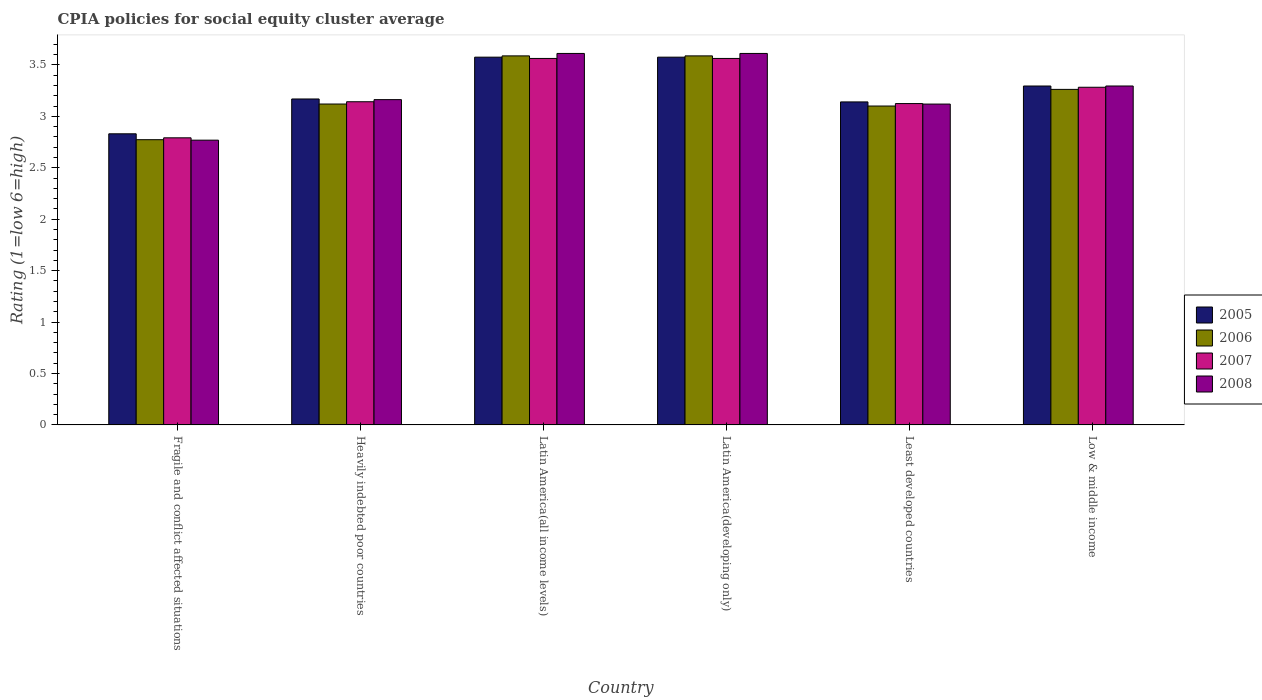Are the number of bars on each tick of the X-axis equal?
Your response must be concise. Yes. How many bars are there on the 6th tick from the left?
Provide a short and direct response. 4. How many bars are there on the 6th tick from the right?
Offer a terse response. 4. What is the label of the 3rd group of bars from the left?
Ensure brevity in your answer.  Latin America(all income levels). In how many cases, is the number of bars for a given country not equal to the number of legend labels?
Provide a short and direct response. 0. Across all countries, what is the maximum CPIA rating in 2006?
Provide a short and direct response. 3.59. Across all countries, what is the minimum CPIA rating in 2008?
Your response must be concise. 2.77. In which country was the CPIA rating in 2005 maximum?
Offer a terse response. Latin America(all income levels). In which country was the CPIA rating in 2008 minimum?
Provide a short and direct response. Fragile and conflict affected situations. What is the total CPIA rating in 2008 in the graph?
Offer a very short reply. 19.57. What is the difference between the CPIA rating in 2008 in Latin America(all income levels) and that in Low & middle income?
Provide a short and direct response. 0.32. What is the difference between the CPIA rating in 2007 in Heavily indebted poor countries and the CPIA rating in 2008 in Low & middle income?
Ensure brevity in your answer.  -0.15. What is the average CPIA rating in 2005 per country?
Offer a terse response. 3.26. What is the difference between the CPIA rating of/in 2005 and CPIA rating of/in 2006 in Latin America(all income levels)?
Provide a short and direct response. -0.01. In how many countries, is the CPIA rating in 2007 greater than 3.3?
Make the answer very short. 2. What is the ratio of the CPIA rating in 2007 in Fragile and conflict affected situations to that in Least developed countries?
Your answer should be compact. 0.89. Is the CPIA rating in 2006 in Latin America(all income levels) less than that in Latin America(developing only)?
Provide a succinct answer. No. What is the difference between the highest and the second highest CPIA rating in 2005?
Make the answer very short. -0.28. What is the difference between the highest and the lowest CPIA rating in 2007?
Provide a short and direct response. 0.77. In how many countries, is the CPIA rating in 2006 greater than the average CPIA rating in 2006 taken over all countries?
Provide a succinct answer. 3. Is the sum of the CPIA rating in 2008 in Latin America(all income levels) and Low & middle income greater than the maximum CPIA rating in 2007 across all countries?
Provide a succinct answer. Yes. What does the 4th bar from the right in Latin America(developing only) represents?
Give a very brief answer. 2005. Is it the case that in every country, the sum of the CPIA rating in 2005 and CPIA rating in 2007 is greater than the CPIA rating in 2008?
Give a very brief answer. Yes. How many bars are there?
Make the answer very short. 24. How many countries are there in the graph?
Your answer should be very brief. 6. Are the values on the major ticks of Y-axis written in scientific E-notation?
Ensure brevity in your answer.  No. How many legend labels are there?
Ensure brevity in your answer.  4. How are the legend labels stacked?
Your answer should be compact. Vertical. What is the title of the graph?
Give a very brief answer. CPIA policies for social equity cluster average. Does "2005" appear as one of the legend labels in the graph?
Make the answer very short. Yes. What is the label or title of the X-axis?
Give a very brief answer. Country. What is the label or title of the Y-axis?
Offer a terse response. Rating (1=low 6=high). What is the Rating (1=low 6=high) of 2005 in Fragile and conflict affected situations?
Provide a short and direct response. 2.83. What is the Rating (1=low 6=high) of 2006 in Fragile and conflict affected situations?
Keep it short and to the point. 2.77. What is the Rating (1=low 6=high) in 2007 in Fragile and conflict affected situations?
Your response must be concise. 2.79. What is the Rating (1=low 6=high) of 2008 in Fragile and conflict affected situations?
Offer a very short reply. 2.77. What is the Rating (1=low 6=high) of 2005 in Heavily indebted poor countries?
Offer a terse response. 3.17. What is the Rating (1=low 6=high) in 2006 in Heavily indebted poor countries?
Keep it short and to the point. 3.12. What is the Rating (1=low 6=high) in 2007 in Heavily indebted poor countries?
Your answer should be compact. 3.14. What is the Rating (1=low 6=high) in 2008 in Heavily indebted poor countries?
Keep it short and to the point. 3.16. What is the Rating (1=low 6=high) in 2005 in Latin America(all income levels)?
Your answer should be very brief. 3.58. What is the Rating (1=low 6=high) in 2006 in Latin America(all income levels)?
Your response must be concise. 3.59. What is the Rating (1=low 6=high) in 2007 in Latin America(all income levels)?
Provide a short and direct response. 3.56. What is the Rating (1=low 6=high) of 2008 in Latin America(all income levels)?
Keep it short and to the point. 3.61. What is the Rating (1=low 6=high) of 2005 in Latin America(developing only)?
Keep it short and to the point. 3.58. What is the Rating (1=low 6=high) in 2006 in Latin America(developing only)?
Make the answer very short. 3.59. What is the Rating (1=low 6=high) of 2007 in Latin America(developing only)?
Offer a very short reply. 3.56. What is the Rating (1=low 6=high) in 2008 in Latin America(developing only)?
Provide a short and direct response. 3.61. What is the Rating (1=low 6=high) of 2005 in Least developed countries?
Your response must be concise. 3.14. What is the Rating (1=low 6=high) of 2007 in Least developed countries?
Your answer should be compact. 3.12. What is the Rating (1=low 6=high) in 2008 in Least developed countries?
Provide a short and direct response. 3.12. What is the Rating (1=low 6=high) of 2005 in Low & middle income?
Provide a succinct answer. 3.29. What is the Rating (1=low 6=high) of 2006 in Low & middle income?
Give a very brief answer. 3.26. What is the Rating (1=low 6=high) of 2007 in Low & middle income?
Your response must be concise. 3.28. What is the Rating (1=low 6=high) in 2008 in Low & middle income?
Offer a terse response. 3.29. Across all countries, what is the maximum Rating (1=low 6=high) in 2005?
Make the answer very short. 3.58. Across all countries, what is the maximum Rating (1=low 6=high) in 2006?
Ensure brevity in your answer.  3.59. Across all countries, what is the maximum Rating (1=low 6=high) in 2007?
Your answer should be compact. 3.56. Across all countries, what is the maximum Rating (1=low 6=high) in 2008?
Give a very brief answer. 3.61. Across all countries, what is the minimum Rating (1=low 6=high) of 2005?
Ensure brevity in your answer.  2.83. Across all countries, what is the minimum Rating (1=low 6=high) in 2006?
Your answer should be very brief. 2.77. Across all countries, what is the minimum Rating (1=low 6=high) in 2007?
Offer a terse response. 2.79. Across all countries, what is the minimum Rating (1=low 6=high) in 2008?
Ensure brevity in your answer.  2.77. What is the total Rating (1=low 6=high) in 2005 in the graph?
Keep it short and to the point. 19.58. What is the total Rating (1=low 6=high) of 2006 in the graph?
Offer a terse response. 19.43. What is the total Rating (1=low 6=high) of 2007 in the graph?
Provide a succinct answer. 19.46. What is the total Rating (1=low 6=high) in 2008 in the graph?
Your response must be concise. 19.57. What is the difference between the Rating (1=low 6=high) of 2005 in Fragile and conflict affected situations and that in Heavily indebted poor countries?
Your answer should be very brief. -0.34. What is the difference between the Rating (1=low 6=high) in 2006 in Fragile and conflict affected situations and that in Heavily indebted poor countries?
Your answer should be compact. -0.35. What is the difference between the Rating (1=low 6=high) in 2007 in Fragile and conflict affected situations and that in Heavily indebted poor countries?
Make the answer very short. -0.35. What is the difference between the Rating (1=low 6=high) in 2008 in Fragile and conflict affected situations and that in Heavily indebted poor countries?
Your answer should be compact. -0.39. What is the difference between the Rating (1=low 6=high) in 2005 in Fragile and conflict affected situations and that in Latin America(all income levels)?
Your answer should be very brief. -0.74. What is the difference between the Rating (1=low 6=high) of 2006 in Fragile and conflict affected situations and that in Latin America(all income levels)?
Your answer should be compact. -0.81. What is the difference between the Rating (1=low 6=high) of 2007 in Fragile and conflict affected situations and that in Latin America(all income levels)?
Your response must be concise. -0.77. What is the difference between the Rating (1=low 6=high) of 2008 in Fragile and conflict affected situations and that in Latin America(all income levels)?
Provide a short and direct response. -0.84. What is the difference between the Rating (1=low 6=high) in 2005 in Fragile and conflict affected situations and that in Latin America(developing only)?
Make the answer very short. -0.74. What is the difference between the Rating (1=low 6=high) of 2006 in Fragile and conflict affected situations and that in Latin America(developing only)?
Give a very brief answer. -0.81. What is the difference between the Rating (1=low 6=high) of 2007 in Fragile and conflict affected situations and that in Latin America(developing only)?
Provide a succinct answer. -0.77. What is the difference between the Rating (1=low 6=high) of 2008 in Fragile and conflict affected situations and that in Latin America(developing only)?
Provide a succinct answer. -0.84. What is the difference between the Rating (1=low 6=high) in 2005 in Fragile and conflict affected situations and that in Least developed countries?
Keep it short and to the point. -0.31. What is the difference between the Rating (1=low 6=high) in 2006 in Fragile and conflict affected situations and that in Least developed countries?
Keep it short and to the point. -0.33. What is the difference between the Rating (1=low 6=high) in 2007 in Fragile and conflict affected situations and that in Least developed countries?
Ensure brevity in your answer.  -0.33. What is the difference between the Rating (1=low 6=high) in 2008 in Fragile and conflict affected situations and that in Least developed countries?
Provide a succinct answer. -0.35. What is the difference between the Rating (1=low 6=high) in 2005 in Fragile and conflict affected situations and that in Low & middle income?
Ensure brevity in your answer.  -0.46. What is the difference between the Rating (1=low 6=high) of 2006 in Fragile and conflict affected situations and that in Low & middle income?
Give a very brief answer. -0.49. What is the difference between the Rating (1=low 6=high) of 2007 in Fragile and conflict affected situations and that in Low & middle income?
Ensure brevity in your answer.  -0.49. What is the difference between the Rating (1=low 6=high) in 2008 in Fragile and conflict affected situations and that in Low & middle income?
Provide a short and direct response. -0.53. What is the difference between the Rating (1=low 6=high) of 2005 in Heavily indebted poor countries and that in Latin America(all income levels)?
Offer a very short reply. -0.41. What is the difference between the Rating (1=low 6=high) in 2006 in Heavily indebted poor countries and that in Latin America(all income levels)?
Provide a succinct answer. -0.47. What is the difference between the Rating (1=low 6=high) in 2007 in Heavily indebted poor countries and that in Latin America(all income levels)?
Provide a short and direct response. -0.42. What is the difference between the Rating (1=low 6=high) of 2008 in Heavily indebted poor countries and that in Latin America(all income levels)?
Your response must be concise. -0.45. What is the difference between the Rating (1=low 6=high) in 2005 in Heavily indebted poor countries and that in Latin America(developing only)?
Make the answer very short. -0.41. What is the difference between the Rating (1=low 6=high) of 2006 in Heavily indebted poor countries and that in Latin America(developing only)?
Provide a succinct answer. -0.47. What is the difference between the Rating (1=low 6=high) of 2007 in Heavily indebted poor countries and that in Latin America(developing only)?
Provide a succinct answer. -0.42. What is the difference between the Rating (1=low 6=high) of 2008 in Heavily indebted poor countries and that in Latin America(developing only)?
Provide a short and direct response. -0.45. What is the difference between the Rating (1=low 6=high) in 2005 in Heavily indebted poor countries and that in Least developed countries?
Ensure brevity in your answer.  0.03. What is the difference between the Rating (1=low 6=high) of 2006 in Heavily indebted poor countries and that in Least developed countries?
Your answer should be compact. 0.02. What is the difference between the Rating (1=low 6=high) in 2007 in Heavily indebted poor countries and that in Least developed countries?
Ensure brevity in your answer.  0.02. What is the difference between the Rating (1=low 6=high) of 2008 in Heavily indebted poor countries and that in Least developed countries?
Offer a very short reply. 0.04. What is the difference between the Rating (1=low 6=high) in 2005 in Heavily indebted poor countries and that in Low & middle income?
Offer a very short reply. -0.13. What is the difference between the Rating (1=low 6=high) of 2006 in Heavily indebted poor countries and that in Low & middle income?
Provide a succinct answer. -0.14. What is the difference between the Rating (1=low 6=high) in 2007 in Heavily indebted poor countries and that in Low & middle income?
Your answer should be very brief. -0.14. What is the difference between the Rating (1=low 6=high) of 2008 in Heavily indebted poor countries and that in Low & middle income?
Ensure brevity in your answer.  -0.13. What is the difference between the Rating (1=low 6=high) in 2007 in Latin America(all income levels) and that in Latin America(developing only)?
Make the answer very short. 0. What is the difference between the Rating (1=low 6=high) of 2008 in Latin America(all income levels) and that in Latin America(developing only)?
Give a very brief answer. 0. What is the difference between the Rating (1=low 6=high) in 2005 in Latin America(all income levels) and that in Least developed countries?
Offer a very short reply. 0.43. What is the difference between the Rating (1=low 6=high) of 2006 in Latin America(all income levels) and that in Least developed countries?
Keep it short and to the point. 0.49. What is the difference between the Rating (1=low 6=high) in 2007 in Latin America(all income levels) and that in Least developed countries?
Offer a very short reply. 0.44. What is the difference between the Rating (1=low 6=high) of 2008 in Latin America(all income levels) and that in Least developed countries?
Ensure brevity in your answer.  0.49. What is the difference between the Rating (1=low 6=high) of 2005 in Latin America(all income levels) and that in Low & middle income?
Provide a short and direct response. 0.28. What is the difference between the Rating (1=low 6=high) in 2006 in Latin America(all income levels) and that in Low & middle income?
Provide a short and direct response. 0.33. What is the difference between the Rating (1=low 6=high) in 2007 in Latin America(all income levels) and that in Low & middle income?
Keep it short and to the point. 0.28. What is the difference between the Rating (1=low 6=high) of 2008 in Latin America(all income levels) and that in Low & middle income?
Keep it short and to the point. 0.32. What is the difference between the Rating (1=low 6=high) in 2005 in Latin America(developing only) and that in Least developed countries?
Offer a terse response. 0.43. What is the difference between the Rating (1=low 6=high) in 2006 in Latin America(developing only) and that in Least developed countries?
Keep it short and to the point. 0.49. What is the difference between the Rating (1=low 6=high) in 2007 in Latin America(developing only) and that in Least developed countries?
Keep it short and to the point. 0.44. What is the difference between the Rating (1=low 6=high) in 2008 in Latin America(developing only) and that in Least developed countries?
Your answer should be very brief. 0.49. What is the difference between the Rating (1=low 6=high) of 2005 in Latin America(developing only) and that in Low & middle income?
Make the answer very short. 0.28. What is the difference between the Rating (1=low 6=high) in 2006 in Latin America(developing only) and that in Low & middle income?
Keep it short and to the point. 0.33. What is the difference between the Rating (1=low 6=high) of 2007 in Latin America(developing only) and that in Low & middle income?
Your answer should be compact. 0.28. What is the difference between the Rating (1=low 6=high) in 2008 in Latin America(developing only) and that in Low & middle income?
Your answer should be compact. 0.32. What is the difference between the Rating (1=low 6=high) of 2005 in Least developed countries and that in Low & middle income?
Provide a succinct answer. -0.15. What is the difference between the Rating (1=low 6=high) in 2006 in Least developed countries and that in Low & middle income?
Ensure brevity in your answer.  -0.16. What is the difference between the Rating (1=low 6=high) in 2007 in Least developed countries and that in Low & middle income?
Offer a terse response. -0.16. What is the difference between the Rating (1=low 6=high) in 2008 in Least developed countries and that in Low & middle income?
Provide a succinct answer. -0.18. What is the difference between the Rating (1=low 6=high) of 2005 in Fragile and conflict affected situations and the Rating (1=low 6=high) of 2006 in Heavily indebted poor countries?
Give a very brief answer. -0.29. What is the difference between the Rating (1=low 6=high) in 2005 in Fragile and conflict affected situations and the Rating (1=low 6=high) in 2007 in Heavily indebted poor countries?
Your answer should be compact. -0.31. What is the difference between the Rating (1=low 6=high) in 2005 in Fragile and conflict affected situations and the Rating (1=low 6=high) in 2008 in Heavily indebted poor countries?
Your answer should be compact. -0.33. What is the difference between the Rating (1=low 6=high) of 2006 in Fragile and conflict affected situations and the Rating (1=low 6=high) of 2007 in Heavily indebted poor countries?
Ensure brevity in your answer.  -0.37. What is the difference between the Rating (1=low 6=high) in 2006 in Fragile and conflict affected situations and the Rating (1=low 6=high) in 2008 in Heavily indebted poor countries?
Your response must be concise. -0.39. What is the difference between the Rating (1=low 6=high) in 2007 in Fragile and conflict affected situations and the Rating (1=low 6=high) in 2008 in Heavily indebted poor countries?
Offer a terse response. -0.37. What is the difference between the Rating (1=low 6=high) of 2005 in Fragile and conflict affected situations and the Rating (1=low 6=high) of 2006 in Latin America(all income levels)?
Make the answer very short. -0.76. What is the difference between the Rating (1=low 6=high) of 2005 in Fragile and conflict affected situations and the Rating (1=low 6=high) of 2007 in Latin America(all income levels)?
Keep it short and to the point. -0.73. What is the difference between the Rating (1=low 6=high) in 2005 in Fragile and conflict affected situations and the Rating (1=low 6=high) in 2008 in Latin America(all income levels)?
Provide a short and direct response. -0.78. What is the difference between the Rating (1=low 6=high) of 2006 in Fragile and conflict affected situations and the Rating (1=low 6=high) of 2007 in Latin America(all income levels)?
Your answer should be very brief. -0.79. What is the difference between the Rating (1=low 6=high) of 2006 in Fragile and conflict affected situations and the Rating (1=low 6=high) of 2008 in Latin America(all income levels)?
Keep it short and to the point. -0.84. What is the difference between the Rating (1=low 6=high) in 2007 in Fragile and conflict affected situations and the Rating (1=low 6=high) in 2008 in Latin America(all income levels)?
Offer a very short reply. -0.82. What is the difference between the Rating (1=low 6=high) in 2005 in Fragile and conflict affected situations and the Rating (1=low 6=high) in 2006 in Latin America(developing only)?
Your answer should be very brief. -0.76. What is the difference between the Rating (1=low 6=high) of 2005 in Fragile and conflict affected situations and the Rating (1=low 6=high) of 2007 in Latin America(developing only)?
Your answer should be compact. -0.73. What is the difference between the Rating (1=low 6=high) in 2005 in Fragile and conflict affected situations and the Rating (1=low 6=high) in 2008 in Latin America(developing only)?
Make the answer very short. -0.78. What is the difference between the Rating (1=low 6=high) in 2006 in Fragile and conflict affected situations and the Rating (1=low 6=high) in 2007 in Latin America(developing only)?
Offer a very short reply. -0.79. What is the difference between the Rating (1=low 6=high) of 2006 in Fragile and conflict affected situations and the Rating (1=low 6=high) of 2008 in Latin America(developing only)?
Offer a terse response. -0.84. What is the difference between the Rating (1=low 6=high) in 2007 in Fragile and conflict affected situations and the Rating (1=low 6=high) in 2008 in Latin America(developing only)?
Keep it short and to the point. -0.82. What is the difference between the Rating (1=low 6=high) of 2005 in Fragile and conflict affected situations and the Rating (1=low 6=high) of 2006 in Least developed countries?
Make the answer very short. -0.27. What is the difference between the Rating (1=low 6=high) in 2005 in Fragile and conflict affected situations and the Rating (1=low 6=high) in 2007 in Least developed countries?
Your response must be concise. -0.29. What is the difference between the Rating (1=low 6=high) in 2005 in Fragile and conflict affected situations and the Rating (1=low 6=high) in 2008 in Least developed countries?
Your answer should be compact. -0.29. What is the difference between the Rating (1=low 6=high) in 2006 in Fragile and conflict affected situations and the Rating (1=low 6=high) in 2007 in Least developed countries?
Provide a short and direct response. -0.35. What is the difference between the Rating (1=low 6=high) of 2006 in Fragile and conflict affected situations and the Rating (1=low 6=high) of 2008 in Least developed countries?
Make the answer very short. -0.35. What is the difference between the Rating (1=low 6=high) in 2007 in Fragile and conflict affected situations and the Rating (1=low 6=high) in 2008 in Least developed countries?
Provide a succinct answer. -0.33. What is the difference between the Rating (1=low 6=high) of 2005 in Fragile and conflict affected situations and the Rating (1=low 6=high) of 2006 in Low & middle income?
Offer a terse response. -0.43. What is the difference between the Rating (1=low 6=high) of 2005 in Fragile and conflict affected situations and the Rating (1=low 6=high) of 2007 in Low & middle income?
Offer a terse response. -0.45. What is the difference between the Rating (1=low 6=high) of 2005 in Fragile and conflict affected situations and the Rating (1=low 6=high) of 2008 in Low & middle income?
Keep it short and to the point. -0.46. What is the difference between the Rating (1=low 6=high) of 2006 in Fragile and conflict affected situations and the Rating (1=low 6=high) of 2007 in Low & middle income?
Your response must be concise. -0.51. What is the difference between the Rating (1=low 6=high) in 2006 in Fragile and conflict affected situations and the Rating (1=low 6=high) in 2008 in Low & middle income?
Provide a succinct answer. -0.52. What is the difference between the Rating (1=low 6=high) of 2007 in Fragile and conflict affected situations and the Rating (1=low 6=high) of 2008 in Low & middle income?
Provide a short and direct response. -0.5. What is the difference between the Rating (1=low 6=high) of 2005 in Heavily indebted poor countries and the Rating (1=low 6=high) of 2006 in Latin America(all income levels)?
Your answer should be compact. -0.42. What is the difference between the Rating (1=low 6=high) in 2005 in Heavily indebted poor countries and the Rating (1=low 6=high) in 2007 in Latin America(all income levels)?
Make the answer very short. -0.39. What is the difference between the Rating (1=low 6=high) of 2005 in Heavily indebted poor countries and the Rating (1=low 6=high) of 2008 in Latin America(all income levels)?
Your answer should be compact. -0.44. What is the difference between the Rating (1=low 6=high) in 2006 in Heavily indebted poor countries and the Rating (1=low 6=high) in 2007 in Latin America(all income levels)?
Give a very brief answer. -0.44. What is the difference between the Rating (1=low 6=high) of 2006 in Heavily indebted poor countries and the Rating (1=low 6=high) of 2008 in Latin America(all income levels)?
Make the answer very short. -0.49. What is the difference between the Rating (1=low 6=high) of 2007 in Heavily indebted poor countries and the Rating (1=low 6=high) of 2008 in Latin America(all income levels)?
Provide a short and direct response. -0.47. What is the difference between the Rating (1=low 6=high) in 2005 in Heavily indebted poor countries and the Rating (1=low 6=high) in 2006 in Latin America(developing only)?
Keep it short and to the point. -0.42. What is the difference between the Rating (1=low 6=high) of 2005 in Heavily indebted poor countries and the Rating (1=low 6=high) of 2007 in Latin America(developing only)?
Your answer should be very brief. -0.39. What is the difference between the Rating (1=low 6=high) in 2005 in Heavily indebted poor countries and the Rating (1=low 6=high) in 2008 in Latin America(developing only)?
Provide a short and direct response. -0.44. What is the difference between the Rating (1=low 6=high) of 2006 in Heavily indebted poor countries and the Rating (1=low 6=high) of 2007 in Latin America(developing only)?
Offer a very short reply. -0.44. What is the difference between the Rating (1=low 6=high) in 2006 in Heavily indebted poor countries and the Rating (1=low 6=high) in 2008 in Latin America(developing only)?
Offer a terse response. -0.49. What is the difference between the Rating (1=low 6=high) of 2007 in Heavily indebted poor countries and the Rating (1=low 6=high) of 2008 in Latin America(developing only)?
Keep it short and to the point. -0.47. What is the difference between the Rating (1=low 6=high) in 2005 in Heavily indebted poor countries and the Rating (1=low 6=high) in 2006 in Least developed countries?
Provide a succinct answer. 0.07. What is the difference between the Rating (1=low 6=high) in 2005 in Heavily indebted poor countries and the Rating (1=low 6=high) in 2007 in Least developed countries?
Make the answer very short. 0.04. What is the difference between the Rating (1=low 6=high) in 2005 in Heavily indebted poor countries and the Rating (1=low 6=high) in 2008 in Least developed countries?
Provide a succinct answer. 0.05. What is the difference between the Rating (1=low 6=high) in 2006 in Heavily indebted poor countries and the Rating (1=low 6=high) in 2007 in Least developed countries?
Provide a succinct answer. -0. What is the difference between the Rating (1=low 6=high) in 2007 in Heavily indebted poor countries and the Rating (1=low 6=high) in 2008 in Least developed countries?
Your answer should be very brief. 0.02. What is the difference between the Rating (1=low 6=high) of 2005 in Heavily indebted poor countries and the Rating (1=low 6=high) of 2006 in Low & middle income?
Ensure brevity in your answer.  -0.09. What is the difference between the Rating (1=low 6=high) of 2005 in Heavily indebted poor countries and the Rating (1=low 6=high) of 2007 in Low & middle income?
Offer a very short reply. -0.11. What is the difference between the Rating (1=low 6=high) of 2005 in Heavily indebted poor countries and the Rating (1=low 6=high) of 2008 in Low & middle income?
Ensure brevity in your answer.  -0.13. What is the difference between the Rating (1=low 6=high) of 2006 in Heavily indebted poor countries and the Rating (1=low 6=high) of 2007 in Low & middle income?
Make the answer very short. -0.16. What is the difference between the Rating (1=low 6=high) of 2006 in Heavily indebted poor countries and the Rating (1=low 6=high) of 2008 in Low & middle income?
Offer a very short reply. -0.18. What is the difference between the Rating (1=low 6=high) of 2007 in Heavily indebted poor countries and the Rating (1=low 6=high) of 2008 in Low & middle income?
Your answer should be compact. -0.15. What is the difference between the Rating (1=low 6=high) in 2005 in Latin America(all income levels) and the Rating (1=low 6=high) in 2006 in Latin America(developing only)?
Offer a terse response. -0.01. What is the difference between the Rating (1=low 6=high) of 2005 in Latin America(all income levels) and the Rating (1=low 6=high) of 2007 in Latin America(developing only)?
Your answer should be very brief. 0.01. What is the difference between the Rating (1=low 6=high) of 2005 in Latin America(all income levels) and the Rating (1=low 6=high) of 2008 in Latin America(developing only)?
Your answer should be very brief. -0.04. What is the difference between the Rating (1=low 6=high) of 2006 in Latin America(all income levels) and the Rating (1=low 6=high) of 2007 in Latin America(developing only)?
Ensure brevity in your answer.  0.03. What is the difference between the Rating (1=low 6=high) of 2006 in Latin America(all income levels) and the Rating (1=low 6=high) of 2008 in Latin America(developing only)?
Provide a short and direct response. -0.02. What is the difference between the Rating (1=low 6=high) of 2007 in Latin America(all income levels) and the Rating (1=low 6=high) of 2008 in Latin America(developing only)?
Keep it short and to the point. -0.05. What is the difference between the Rating (1=low 6=high) in 2005 in Latin America(all income levels) and the Rating (1=low 6=high) in 2006 in Least developed countries?
Ensure brevity in your answer.  0.47. What is the difference between the Rating (1=low 6=high) of 2005 in Latin America(all income levels) and the Rating (1=low 6=high) of 2007 in Least developed countries?
Ensure brevity in your answer.  0.45. What is the difference between the Rating (1=low 6=high) of 2005 in Latin America(all income levels) and the Rating (1=low 6=high) of 2008 in Least developed countries?
Your answer should be very brief. 0.46. What is the difference between the Rating (1=low 6=high) of 2006 in Latin America(all income levels) and the Rating (1=low 6=high) of 2007 in Least developed countries?
Your answer should be very brief. 0.46. What is the difference between the Rating (1=low 6=high) in 2006 in Latin America(all income levels) and the Rating (1=low 6=high) in 2008 in Least developed countries?
Ensure brevity in your answer.  0.47. What is the difference between the Rating (1=low 6=high) of 2007 in Latin America(all income levels) and the Rating (1=low 6=high) of 2008 in Least developed countries?
Your response must be concise. 0.44. What is the difference between the Rating (1=low 6=high) of 2005 in Latin America(all income levels) and the Rating (1=low 6=high) of 2006 in Low & middle income?
Your answer should be compact. 0.31. What is the difference between the Rating (1=low 6=high) in 2005 in Latin America(all income levels) and the Rating (1=low 6=high) in 2007 in Low & middle income?
Offer a terse response. 0.29. What is the difference between the Rating (1=low 6=high) of 2005 in Latin America(all income levels) and the Rating (1=low 6=high) of 2008 in Low & middle income?
Your answer should be very brief. 0.28. What is the difference between the Rating (1=low 6=high) of 2006 in Latin America(all income levels) and the Rating (1=low 6=high) of 2007 in Low & middle income?
Make the answer very short. 0.31. What is the difference between the Rating (1=low 6=high) in 2006 in Latin America(all income levels) and the Rating (1=low 6=high) in 2008 in Low & middle income?
Your response must be concise. 0.29. What is the difference between the Rating (1=low 6=high) in 2007 in Latin America(all income levels) and the Rating (1=low 6=high) in 2008 in Low & middle income?
Give a very brief answer. 0.27. What is the difference between the Rating (1=low 6=high) of 2005 in Latin America(developing only) and the Rating (1=low 6=high) of 2006 in Least developed countries?
Provide a succinct answer. 0.47. What is the difference between the Rating (1=low 6=high) in 2005 in Latin America(developing only) and the Rating (1=low 6=high) in 2007 in Least developed countries?
Provide a short and direct response. 0.45. What is the difference between the Rating (1=low 6=high) of 2005 in Latin America(developing only) and the Rating (1=low 6=high) of 2008 in Least developed countries?
Keep it short and to the point. 0.46. What is the difference between the Rating (1=low 6=high) in 2006 in Latin America(developing only) and the Rating (1=low 6=high) in 2007 in Least developed countries?
Your response must be concise. 0.46. What is the difference between the Rating (1=low 6=high) of 2006 in Latin America(developing only) and the Rating (1=low 6=high) of 2008 in Least developed countries?
Give a very brief answer. 0.47. What is the difference between the Rating (1=low 6=high) in 2007 in Latin America(developing only) and the Rating (1=low 6=high) in 2008 in Least developed countries?
Provide a succinct answer. 0.44. What is the difference between the Rating (1=low 6=high) in 2005 in Latin America(developing only) and the Rating (1=low 6=high) in 2006 in Low & middle income?
Provide a succinct answer. 0.31. What is the difference between the Rating (1=low 6=high) of 2005 in Latin America(developing only) and the Rating (1=low 6=high) of 2007 in Low & middle income?
Ensure brevity in your answer.  0.29. What is the difference between the Rating (1=low 6=high) of 2005 in Latin America(developing only) and the Rating (1=low 6=high) of 2008 in Low & middle income?
Your answer should be very brief. 0.28. What is the difference between the Rating (1=low 6=high) in 2006 in Latin America(developing only) and the Rating (1=low 6=high) in 2007 in Low & middle income?
Keep it short and to the point. 0.31. What is the difference between the Rating (1=low 6=high) of 2006 in Latin America(developing only) and the Rating (1=low 6=high) of 2008 in Low & middle income?
Provide a short and direct response. 0.29. What is the difference between the Rating (1=low 6=high) of 2007 in Latin America(developing only) and the Rating (1=low 6=high) of 2008 in Low & middle income?
Your answer should be compact. 0.27. What is the difference between the Rating (1=low 6=high) in 2005 in Least developed countries and the Rating (1=low 6=high) in 2006 in Low & middle income?
Make the answer very short. -0.12. What is the difference between the Rating (1=low 6=high) of 2005 in Least developed countries and the Rating (1=low 6=high) of 2007 in Low & middle income?
Offer a terse response. -0.14. What is the difference between the Rating (1=low 6=high) in 2005 in Least developed countries and the Rating (1=low 6=high) in 2008 in Low & middle income?
Offer a very short reply. -0.15. What is the difference between the Rating (1=low 6=high) of 2006 in Least developed countries and the Rating (1=low 6=high) of 2007 in Low & middle income?
Make the answer very short. -0.18. What is the difference between the Rating (1=low 6=high) in 2006 in Least developed countries and the Rating (1=low 6=high) in 2008 in Low & middle income?
Provide a short and direct response. -0.19. What is the difference between the Rating (1=low 6=high) of 2007 in Least developed countries and the Rating (1=low 6=high) of 2008 in Low & middle income?
Offer a terse response. -0.17. What is the average Rating (1=low 6=high) in 2005 per country?
Provide a short and direct response. 3.26. What is the average Rating (1=low 6=high) in 2006 per country?
Offer a very short reply. 3.24. What is the average Rating (1=low 6=high) in 2007 per country?
Offer a terse response. 3.24. What is the average Rating (1=low 6=high) in 2008 per country?
Your answer should be very brief. 3.26. What is the difference between the Rating (1=low 6=high) in 2005 and Rating (1=low 6=high) in 2006 in Fragile and conflict affected situations?
Keep it short and to the point. 0.06. What is the difference between the Rating (1=low 6=high) in 2005 and Rating (1=low 6=high) in 2007 in Fragile and conflict affected situations?
Your answer should be compact. 0.04. What is the difference between the Rating (1=low 6=high) of 2005 and Rating (1=low 6=high) of 2008 in Fragile and conflict affected situations?
Keep it short and to the point. 0.06. What is the difference between the Rating (1=low 6=high) of 2006 and Rating (1=low 6=high) of 2007 in Fragile and conflict affected situations?
Provide a short and direct response. -0.02. What is the difference between the Rating (1=low 6=high) in 2006 and Rating (1=low 6=high) in 2008 in Fragile and conflict affected situations?
Offer a terse response. 0. What is the difference between the Rating (1=low 6=high) of 2007 and Rating (1=low 6=high) of 2008 in Fragile and conflict affected situations?
Your answer should be very brief. 0.02. What is the difference between the Rating (1=low 6=high) of 2005 and Rating (1=low 6=high) of 2006 in Heavily indebted poor countries?
Offer a terse response. 0.05. What is the difference between the Rating (1=low 6=high) in 2005 and Rating (1=low 6=high) in 2007 in Heavily indebted poor countries?
Your answer should be compact. 0.03. What is the difference between the Rating (1=low 6=high) of 2005 and Rating (1=low 6=high) of 2008 in Heavily indebted poor countries?
Give a very brief answer. 0.01. What is the difference between the Rating (1=low 6=high) of 2006 and Rating (1=low 6=high) of 2007 in Heavily indebted poor countries?
Give a very brief answer. -0.02. What is the difference between the Rating (1=low 6=high) in 2006 and Rating (1=low 6=high) in 2008 in Heavily indebted poor countries?
Offer a terse response. -0.04. What is the difference between the Rating (1=low 6=high) of 2007 and Rating (1=low 6=high) of 2008 in Heavily indebted poor countries?
Your response must be concise. -0.02. What is the difference between the Rating (1=low 6=high) of 2005 and Rating (1=low 6=high) of 2006 in Latin America(all income levels)?
Keep it short and to the point. -0.01. What is the difference between the Rating (1=low 6=high) in 2005 and Rating (1=low 6=high) in 2007 in Latin America(all income levels)?
Keep it short and to the point. 0.01. What is the difference between the Rating (1=low 6=high) of 2005 and Rating (1=low 6=high) of 2008 in Latin America(all income levels)?
Offer a very short reply. -0.04. What is the difference between the Rating (1=low 6=high) of 2006 and Rating (1=low 6=high) of 2007 in Latin America(all income levels)?
Offer a terse response. 0.03. What is the difference between the Rating (1=low 6=high) in 2006 and Rating (1=low 6=high) in 2008 in Latin America(all income levels)?
Your answer should be very brief. -0.02. What is the difference between the Rating (1=low 6=high) in 2007 and Rating (1=low 6=high) in 2008 in Latin America(all income levels)?
Keep it short and to the point. -0.05. What is the difference between the Rating (1=low 6=high) of 2005 and Rating (1=low 6=high) of 2006 in Latin America(developing only)?
Offer a very short reply. -0.01. What is the difference between the Rating (1=low 6=high) of 2005 and Rating (1=low 6=high) of 2007 in Latin America(developing only)?
Offer a terse response. 0.01. What is the difference between the Rating (1=low 6=high) of 2005 and Rating (1=low 6=high) of 2008 in Latin America(developing only)?
Provide a succinct answer. -0.04. What is the difference between the Rating (1=low 6=high) in 2006 and Rating (1=low 6=high) in 2007 in Latin America(developing only)?
Your response must be concise. 0.03. What is the difference between the Rating (1=low 6=high) of 2006 and Rating (1=low 6=high) of 2008 in Latin America(developing only)?
Offer a very short reply. -0.02. What is the difference between the Rating (1=low 6=high) of 2007 and Rating (1=low 6=high) of 2008 in Latin America(developing only)?
Keep it short and to the point. -0.05. What is the difference between the Rating (1=low 6=high) in 2005 and Rating (1=low 6=high) in 2006 in Least developed countries?
Give a very brief answer. 0.04. What is the difference between the Rating (1=low 6=high) of 2005 and Rating (1=low 6=high) of 2007 in Least developed countries?
Give a very brief answer. 0.02. What is the difference between the Rating (1=low 6=high) in 2005 and Rating (1=low 6=high) in 2008 in Least developed countries?
Offer a terse response. 0.02. What is the difference between the Rating (1=low 6=high) of 2006 and Rating (1=low 6=high) of 2007 in Least developed countries?
Give a very brief answer. -0.02. What is the difference between the Rating (1=low 6=high) of 2006 and Rating (1=low 6=high) of 2008 in Least developed countries?
Make the answer very short. -0.02. What is the difference between the Rating (1=low 6=high) of 2007 and Rating (1=low 6=high) of 2008 in Least developed countries?
Provide a short and direct response. 0. What is the difference between the Rating (1=low 6=high) of 2005 and Rating (1=low 6=high) of 2006 in Low & middle income?
Offer a terse response. 0.03. What is the difference between the Rating (1=low 6=high) of 2005 and Rating (1=low 6=high) of 2007 in Low & middle income?
Your answer should be compact. 0.01. What is the difference between the Rating (1=low 6=high) of 2005 and Rating (1=low 6=high) of 2008 in Low & middle income?
Give a very brief answer. -0. What is the difference between the Rating (1=low 6=high) of 2006 and Rating (1=low 6=high) of 2007 in Low & middle income?
Offer a terse response. -0.02. What is the difference between the Rating (1=low 6=high) of 2006 and Rating (1=low 6=high) of 2008 in Low & middle income?
Ensure brevity in your answer.  -0.03. What is the difference between the Rating (1=low 6=high) of 2007 and Rating (1=low 6=high) of 2008 in Low & middle income?
Ensure brevity in your answer.  -0.01. What is the ratio of the Rating (1=low 6=high) in 2005 in Fragile and conflict affected situations to that in Heavily indebted poor countries?
Keep it short and to the point. 0.89. What is the ratio of the Rating (1=low 6=high) of 2007 in Fragile and conflict affected situations to that in Heavily indebted poor countries?
Your response must be concise. 0.89. What is the ratio of the Rating (1=low 6=high) of 2008 in Fragile and conflict affected situations to that in Heavily indebted poor countries?
Provide a short and direct response. 0.88. What is the ratio of the Rating (1=low 6=high) in 2005 in Fragile and conflict affected situations to that in Latin America(all income levels)?
Keep it short and to the point. 0.79. What is the ratio of the Rating (1=low 6=high) in 2006 in Fragile and conflict affected situations to that in Latin America(all income levels)?
Offer a very short reply. 0.77. What is the ratio of the Rating (1=low 6=high) of 2007 in Fragile and conflict affected situations to that in Latin America(all income levels)?
Offer a very short reply. 0.78. What is the ratio of the Rating (1=low 6=high) in 2008 in Fragile and conflict affected situations to that in Latin America(all income levels)?
Provide a short and direct response. 0.77. What is the ratio of the Rating (1=low 6=high) of 2005 in Fragile and conflict affected situations to that in Latin America(developing only)?
Your answer should be compact. 0.79. What is the ratio of the Rating (1=low 6=high) of 2006 in Fragile and conflict affected situations to that in Latin America(developing only)?
Your answer should be compact. 0.77. What is the ratio of the Rating (1=low 6=high) of 2007 in Fragile and conflict affected situations to that in Latin America(developing only)?
Offer a very short reply. 0.78. What is the ratio of the Rating (1=low 6=high) in 2008 in Fragile and conflict affected situations to that in Latin America(developing only)?
Give a very brief answer. 0.77. What is the ratio of the Rating (1=low 6=high) of 2005 in Fragile and conflict affected situations to that in Least developed countries?
Make the answer very short. 0.9. What is the ratio of the Rating (1=low 6=high) of 2006 in Fragile and conflict affected situations to that in Least developed countries?
Your answer should be compact. 0.89. What is the ratio of the Rating (1=low 6=high) in 2007 in Fragile and conflict affected situations to that in Least developed countries?
Your answer should be compact. 0.89. What is the ratio of the Rating (1=low 6=high) in 2008 in Fragile and conflict affected situations to that in Least developed countries?
Your response must be concise. 0.89. What is the ratio of the Rating (1=low 6=high) in 2005 in Fragile and conflict affected situations to that in Low & middle income?
Ensure brevity in your answer.  0.86. What is the ratio of the Rating (1=low 6=high) in 2007 in Fragile and conflict affected situations to that in Low & middle income?
Your answer should be compact. 0.85. What is the ratio of the Rating (1=low 6=high) in 2008 in Fragile and conflict affected situations to that in Low & middle income?
Ensure brevity in your answer.  0.84. What is the ratio of the Rating (1=low 6=high) of 2005 in Heavily indebted poor countries to that in Latin America(all income levels)?
Offer a terse response. 0.89. What is the ratio of the Rating (1=low 6=high) of 2006 in Heavily indebted poor countries to that in Latin America(all income levels)?
Make the answer very short. 0.87. What is the ratio of the Rating (1=low 6=high) of 2007 in Heavily indebted poor countries to that in Latin America(all income levels)?
Your answer should be compact. 0.88. What is the ratio of the Rating (1=low 6=high) in 2008 in Heavily indebted poor countries to that in Latin America(all income levels)?
Offer a very short reply. 0.88. What is the ratio of the Rating (1=low 6=high) of 2005 in Heavily indebted poor countries to that in Latin America(developing only)?
Ensure brevity in your answer.  0.89. What is the ratio of the Rating (1=low 6=high) in 2006 in Heavily indebted poor countries to that in Latin America(developing only)?
Give a very brief answer. 0.87. What is the ratio of the Rating (1=low 6=high) of 2007 in Heavily indebted poor countries to that in Latin America(developing only)?
Give a very brief answer. 0.88. What is the ratio of the Rating (1=low 6=high) of 2008 in Heavily indebted poor countries to that in Latin America(developing only)?
Your answer should be very brief. 0.88. What is the ratio of the Rating (1=low 6=high) in 2005 in Heavily indebted poor countries to that in Least developed countries?
Make the answer very short. 1.01. What is the ratio of the Rating (1=low 6=high) of 2006 in Heavily indebted poor countries to that in Least developed countries?
Ensure brevity in your answer.  1.01. What is the ratio of the Rating (1=low 6=high) in 2008 in Heavily indebted poor countries to that in Least developed countries?
Provide a succinct answer. 1.01. What is the ratio of the Rating (1=low 6=high) of 2005 in Heavily indebted poor countries to that in Low & middle income?
Your answer should be very brief. 0.96. What is the ratio of the Rating (1=low 6=high) in 2006 in Heavily indebted poor countries to that in Low & middle income?
Your response must be concise. 0.96. What is the ratio of the Rating (1=low 6=high) in 2007 in Heavily indebted poor countries to that in Low & middle income?
Your response must be concise. 0.96. What is the ratio of the Rating (1=low 6=high) of 2008 in Heavily indebted poor countries to that in Low & middle income?
Provide a short and direct response. 0.96. What is the ratio of the Rating (1=low 6=high) of 2005 in Latin America(all income levels) to that in Latin America(developing only)?
Offer a very short reply. 1. What is the ratio of the Rating (1=low 6=high) in 2006 in Latin America(all income levels) to that in Latin America(developing only)?
Provide a short and direct response. 1. What is the ratio of the Rating (1=low 6=high) in 2007 in Latin America(all income levels) to that in Latin America(developing only)?
Provide a succinct answer. 1. What is the ratio of the Rating (1=low 6=high) of 2008 in Latin America(all income levels) to that in Latin America(developing only)?
Provide a succinct answer. 1. What is the ratio of the Rating (1=low 6=high) of 2005 in Latin America(all income levels) to that in Least developed countries?
Your answer should be very brief. 1.14. What is the ratio of the Rating (1=low 6=high) in 2006 in Latin America(all income levels) to that in Least developed countries?
Give a very brief answer. 1.16. What is the ratio of the Rating (1=low 6=high) of 2007 in Latin America(all income levels) to that in Least developed countries?
Your answer should be compact. 1.14. What is the ratio of the Rating (1=low 6=high) of 2008 in Latin America(all income levels) to that in Least developed countries?
Provide a short and direct response. 1.16. What is the ratio of the Rating (1=low 6=high) of 2005 in Latin America(all income levels) to that in Low & middle income?
Ensure brevity in your answer.  1.09. What is the ratio of the Rating (1=low 6=high) of 2006 in Latin America(all income levels) to that in Low & middle income?
Ensure brevity in your answer.  1.1. What is the ratio of the Rating (1=low 6=high) in 2007 in Latin America(all income levels) to that in Low & middle income?
Offer a terse response. 1.09. What is the ratio of the Rating (1=low 6=high) of 2008 in Latin America(all income levels) to that in Low & middle income?
Provide a succinct answer. 1.1. What is the ratio of the Rating (1=low 6=high) of 2005 in Latin America(developing only) to that in Least developed countries?
Give a very brief answer. 1.14. What is the ratio of the Rating (1=low 6=high) in 2006 in Latin America(developing only) to that in Least developed countries?
Give a very brief answer. 1.16. What is the ratio of the Rating (1=low 6=high) in 2007 in Latin America(developing only) to that in Least developed countries?
Keep it short and to the point. 1.14. What is the ratio of the Rating (1=low 6=high) of 2008 in Latin America(developing only) to that in Least developed countries?
Keep it short and to the point. 1.16. What is the ratio of the Rating (1=low 6=high) in 2005 in Latin America(developing only) to that in Low & middle income?
Your response must be concise. 1.09. What is the ratio of the Rating (1=low 6=high) in 2006 in Latin America(developing only) to that in Low & middle income?
Provide a short and direct response. 1.1. What is the ratio of the Rating (1=low 6=high) in 2007 in Latin America(developing only) to that in Low & middle income?
Offer a terse response. 1.09. What is the ratio of the Rating (1=low 6=high) in 2008 in Latin America(developing only) to that in Low & middle income?
Offer a very short reply. 1.1. What is the ratio of the Rating (1=low 6=high) in 2005 in Least developed countries to that in Low & middle income?
Provide a short and direct response. 0.95. What is the ratio of the Rating (1=low 6=high) of 2006 in Least developed countries to that in Low & middle income?
Provide a succinct answer. 0.95. What is the ratio of the Rating (1=low 6=high) in 2007 in Least developed countries to that in Low & middle income?
Provide a succinct answer. 0.95. What is the ratio of the Rating (1=low 6=high) in 2008 in Least developed countries to that in Low & middle income?
Make the answer very short. 0.95. What is the difference between the highest and the lowest Rating (1=low 6=high) of 2005?
Keep it short and to the point. 0.74. What is the difference between the highest and the lowest Rating (1=low 6=high) in 2006?
Provide a succinct answer. 0.81. What is the difference between the highest and the lowest Rating (1=low 6=high) of 2007?
Offer a very short reply. 0.77. What is the difference between the highest and the lowest Rating (1=low 6=high) of 2008?
Ensure brevity in your answer.  0.84. 